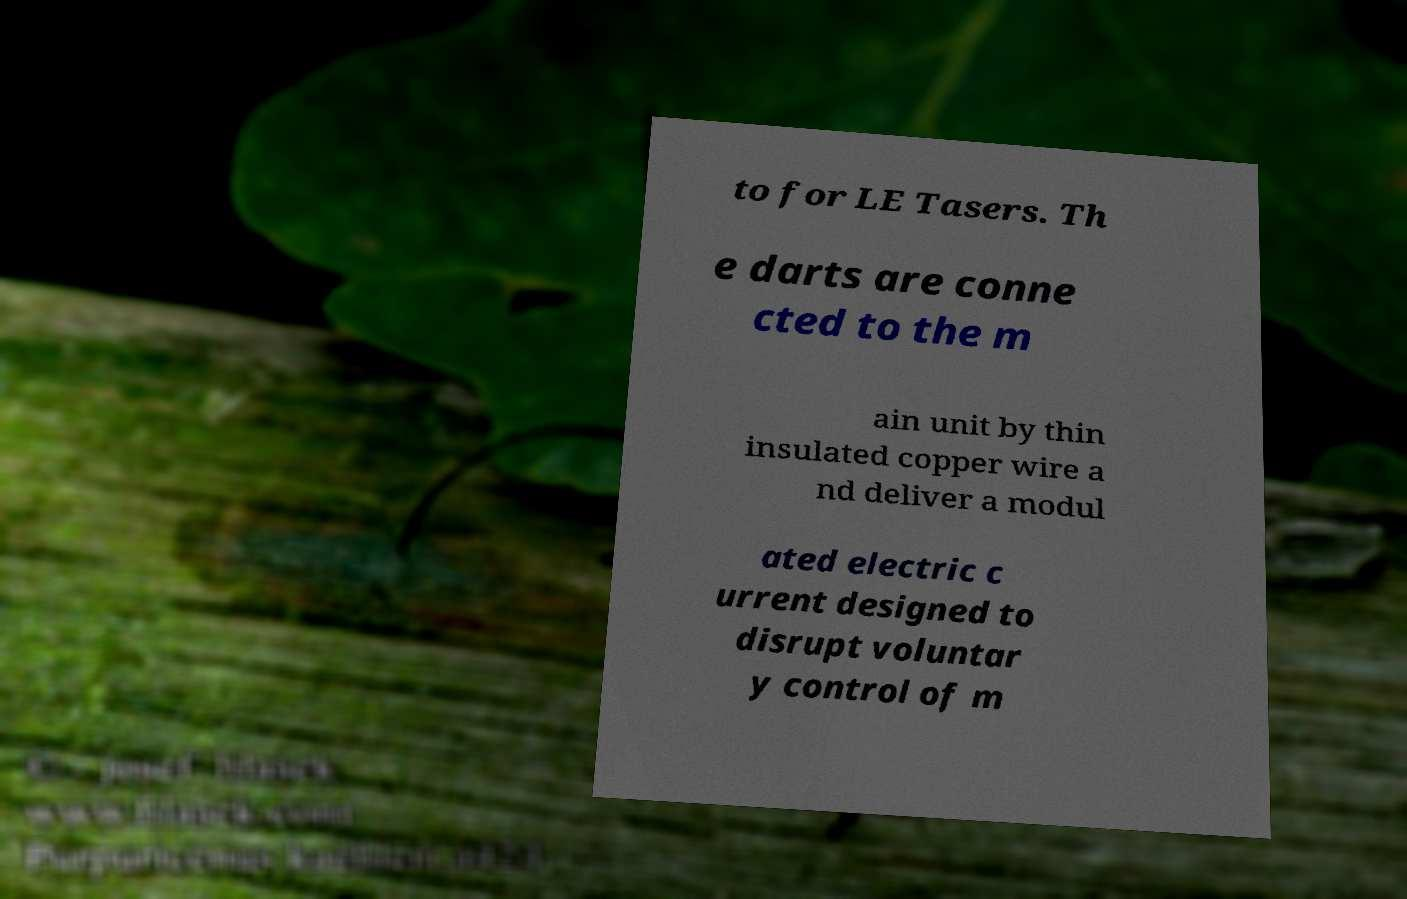Can you read and provide the text displayed in the image?This photo seems to have some interesting text. Can you extract and type it out for me? to for LE Tasers. Th e darts are conne cted to the m ain unit by thin insulated copper wire a nd deliver a modul ated electric c urrent designed to disrupt voluntar y control of m 